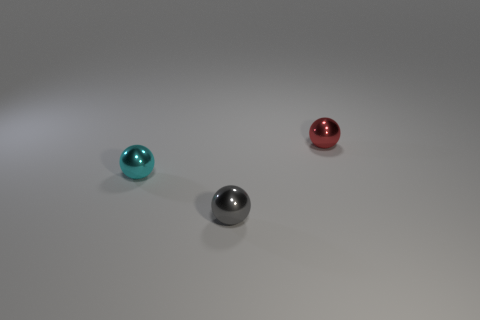Is there a large brown cylinder that has the same material as the red object?
Your answer should be very brief. No. Is the number of small gray balls in front of the tiny red shiny object less than the number of tiny shiny spheres that are on the right side of the tiny cyan shiny thing?
Your answer should be compact. Yes. What number of other objects are the same shape as the tiny red metal thing?
Provide a short and direct response. 2. Are there fewer small metal objects that are behind the tiny red thing than big blue rubber cylinders?
Your answer should be compact. No. What is the tiny sphere to the left of the gray shiny thing made of?
Your answer should be compact. Metal. How many other objects are the same size as the red object?
Your response must be concise. 2. Is the number of tiny spheres less than the number of big brown rubber cylinders?
Keep it short and to the point. No. What is the shape of the gray metal thing?
Your response must be concise. Sphere. What is the shape of the object that is both in front of the red sphere and on the right side of the cyan thing?
Your response must be concise. Sphere. What color is the tiny thing in front of the tiny cyan object?
Keep it short and to the point. Gray. 